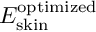<formula> <loc_0><loc_0><loc_500><loc_500>E _ { s k i n } ^ { o p t i m i z e d }</formula> 